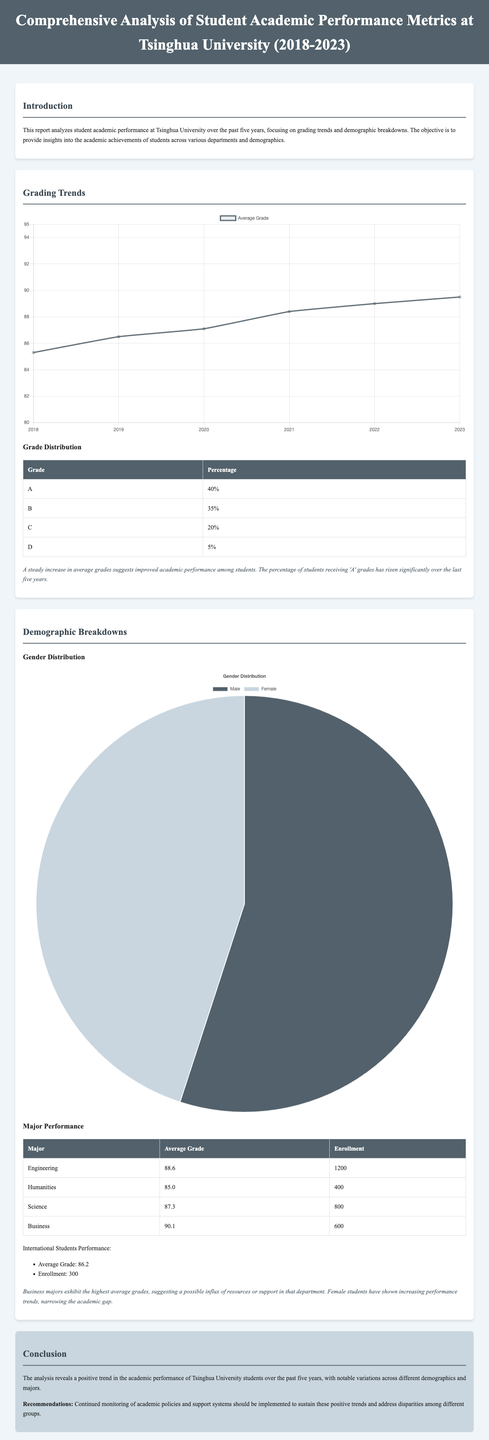What is the average grade for Engineering students? The average grade for Engineering students is provided in the Major Performance table.
Answer: 88.6 What percentage of students received 'A' grades? The percentage of students receiving 'A' grades is mentioned in the Grade Distribution section of the report.
Answer: 40% What year recorded the highest average grade? The highest average grade is found in the Grade Trend Chart, indicating the last year listed.
Answer: 2023 What is the average grade for Business majors? The average grade for Business majors is listed in the Major Performance table.
Answer: 90.1 What is the gender distribution in the student population? The gender distribution is provided in the Gender Distribution Chart, showing the proportions of each gender.
Answer: Male: 55%, Female: 45% What trend is observed in female students' performance? The observation in the Demographic Breakdowns section indicates the performance of female students.
Answer: Increasing performance trends How many international students are mentioned in the report? The report provides the enrollment number of international students in the demographic breakdowns.
Answer: 300 What is the minimum average grade shown in the Grade Trend Chart? The Grade Trend Chart indicates the minimum average grade across the years presented in the document.
Answer: 85.3 What department shows the highest enrollment? The department with the highest enrollment is provided in the Major Performance table.
Answer: Engineering 